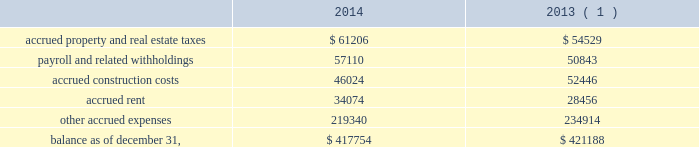American tower corporation and subsidiaries notes to consolidated financial statements acquisition accounting upon closing of the acquisition .
Based on current estimates , the company expects the value of potential contingent consideration payments required to be made under these agreements to be between zero and $ 4.4 million .
During the year ended december 31 , 2014 , the company ( i ) recorded a decrease in fair value of $ 1.7 million in other operating expenses in the accompanying consolidated statements of operations , ( ii ) recorded settlements under these agreements of $ 3.5 million , ( iii ) reduced its contingent consideration liability by $ 0.7 million as a portion of the company 2019s obligations was assumed by the buyer in conjunction with the sale of operations in panama and ( iv ) recorded additional liability of $ 0.1 million .
As a result , the company estimates the value of potential contingent consideration payments required under these agreements to be $ 2.3 million using a probability weighted average of the expected outcomes as of december 31 , 2014 .
Other u.s . 2014in connection with other acquisitions in the united states , the company is required to make additional payments if certain pre-designated tenant leases commence during a specified period of time .
During the year ended december 31 , 2014 , the company recorded $ 6.3 million of contingent consideration liability as part of the preliminary acquisition accounting upon closing of certain acquisitions .
During the year ended december 31 , 2014 , the company recorded settlements under these agreements of $ 0.4 million .
Based on current estimates , the company expects the value of potential contingent consideration payments required to be made under these agreements to be between zero and $ 5.9 million and estimates it to be $ 5.9 million using a probability weighted average of the expected outcomes as of december 31 , 2014 .
For more information regarding contingent consideration , see note 12 .
Accrued expenses accrued expenses consists of the following as of december 31 , ( in thousands ) : .
( 1 ) december 31 , 2013 balances have been revised to reflect purchase accounting measurement period adjustments. .
What was the increase in payroll and related withholdings in 2014 , in millions? 
Computations: (57110 - 50843)
Answer: 6267.0. 